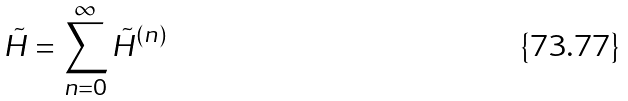<formula> <loc_0><loc_0><loc_500><loc_500>\tilde { H } = \sum _ { n = 0 } ^ { \infty } \tilde { H } ^ { ( n ) }</formula> 